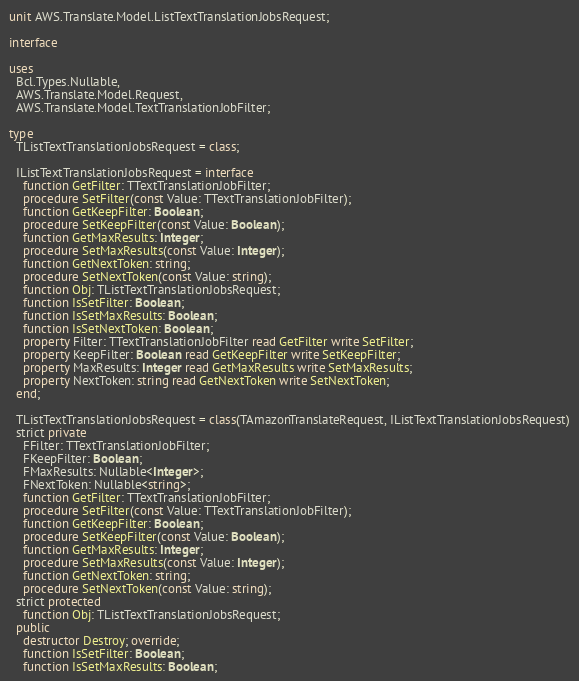<code> <loc_0><loc_0><loc_500><loc_500><_Pascal_>unit AWS.Translate.Model.ListTextTranslationJobsRequest;

interface

uses
  Bcl.Types.Nullable, 
  AWS.Translate.Model.Request, 
  AWS.Translate.Model.TextTranslationJobFilter;

type
  TListTextTranslationJobsRequest = class;
  
  IListTextTranslationJobsRequest = interface
    function GetFilter: TTextTranslationJobFilter;
    procedure SetFilter(const Value: TTextTranslationJobFilter);
    function GetKeepFilter: Boolean;
    procedure SetKeepFilter(const Value: Boolean);
    function GetMaxResults: Integer;
    procedure SetMaxResults(const Value: Integer);
    function GetNextToken: string;
    procedure SetNextToken(const Value: string);
    function Obj: TListTextTranslationJobsRequest;
    function IsSetFilter: Boolean;
    function IsSetMaxResults: Boolean;
    function IsSetNextToken: Boolean;
    property Filter: TTextTranslationJobFilter read GetFilter write SetFilter;
    property KeepFilter: Boolean read GetKeepFilter write SetKeepFilter;
    property MaxResults: Integer read GetMaxResults write SetMaxResults;
    property NextToken: string read GetNextToken write SetNextToken;
  end;
  
  TListTextTranslationJobsRequest = class(TAmazonTranslateRequest, IListTextTranslationJobsRequest)
  strict private
    FFilter: TTextTranslationJobFilter;
    FKeepFilter: Boolean;
    FMaxResults: Nullable<Integer>;
    FNextToken: Nullable<string>;
    function GetFilter: TTextTranslationJobFilter;
    procedure SetFilter(const Value: TTextTranslationJobFilter);
    function GetKeepFilter: Boolean;
    procedure SetKeepFilter(const Value: Boolean);
    function GetMaxResults: Integer;
    procedure SetMaxResults(const Value: Integer);
    function GetNextToken: string;
    procedure SetNextToken(const Value: string);
  strict protected
    function Obj: TListTextTranslationJobsRequest;
  public
    destructor Destroy; override;
    function IsSetFilter: Boolean;
    function IsSetMaxResults: Boolean;</code> 